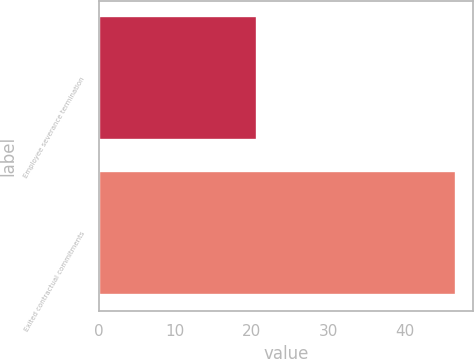Convert chart. <chart><loc_0><loc_0><loc_500><loc_500><bar_chart><fcel>Employee severance termination<fcel>Exited contractual commitments<nl><fcel>20.6<fcel>46.6<nl></chart> 